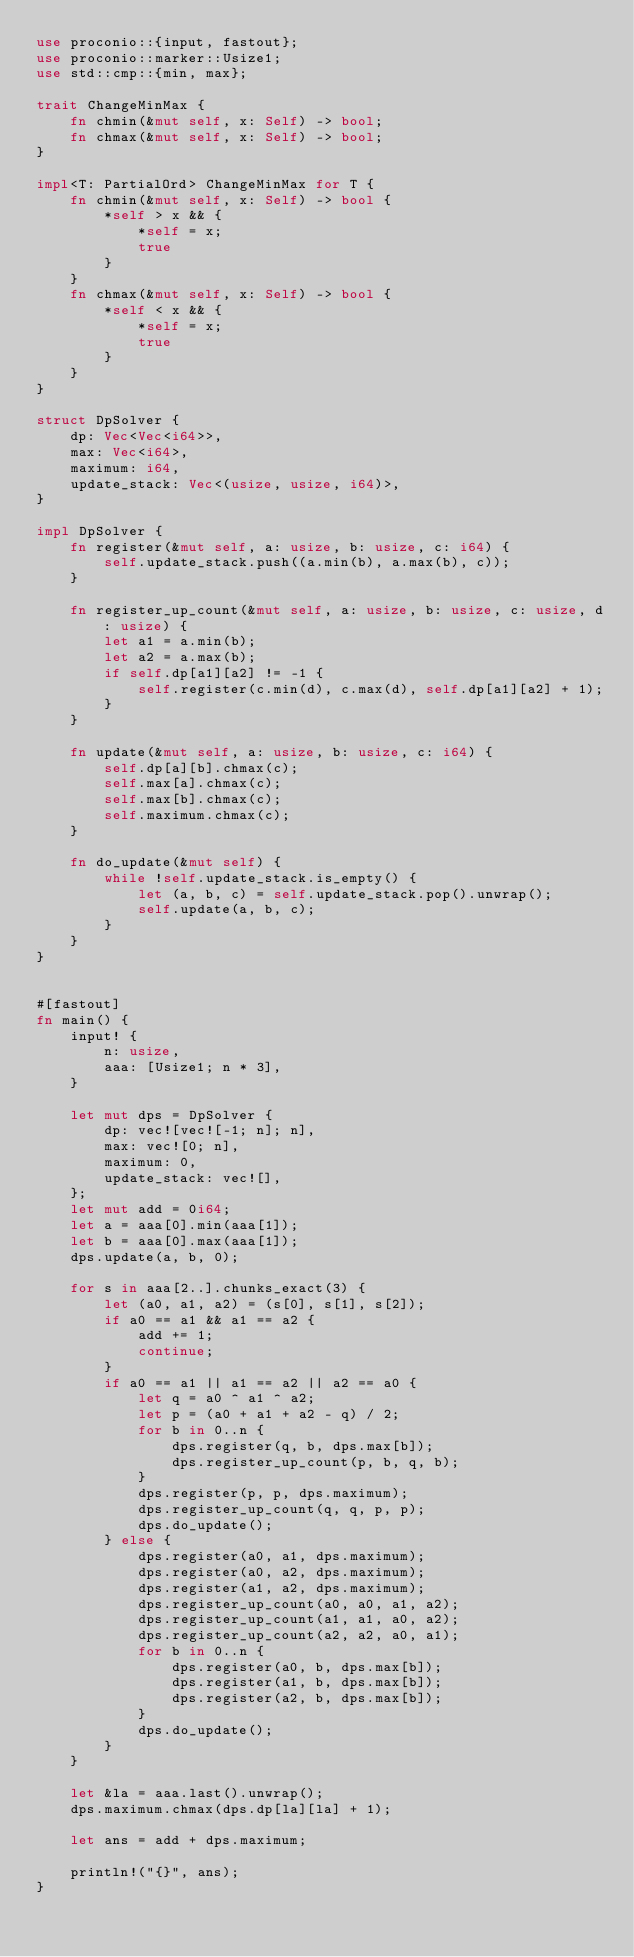Convert code to text. <code><loc_0><loc_0><loc_500><loc_500><_Rust_>use proconio::{input, fastout};
use proconio::marker::Usize1;
use std::cmp::{min, max};

trait ChangeMinMax {
    fn chmin(&mut self, x: Self) -> bool;
    fn chmax(&mut self, x: Self) -> bool;
}

impl<T: PartialOrd> ChangeMinMax for T {
    fn chmin(&mut self, x: Self) -> bool {
        *self > x && {
            *self = x;
            true
        }
    }
    fn chmax(&mut self, x: Self) -> bool {
        *self < x && {
            *self = x;
            true
        }
    }
}

struct DpSolver {
    dp: Vec<Vec<i64>>,
    max: Vec<i64>,
    maximum: i64,
    update_stack: Vec<(usize, usize, i64)>,
}

impl DpSolver {
    fn register(&mut self, a: usize, b: usize, c: i64) {
        self.update_stack.push((a.min(b), a.max(b), c));
    }

    fn register_up_count(&mut self, a: usize, b: usize, c: usize, d: usize) {
        let a1 = a.min(b);
        let a2 = a.max(b);
        if self.dp[a1][a2] != -1 {
            self.register(c.min(d), c.max(d), self.dp[a1][a2] + 1);
        }
    }

    fn update(&mut self, a: usize, b: usize, c: i64) {
        self.dp[a][b].chmax(c);
        self.max[a].chmax(c);
        self.max[b].chmax(c);
        self.maximum.chmax(c);
    }

    fn do_update(&mut self) {
        while !self.update_stack.is_empty() {
            let (a, b, c) = self.update_stack.pop().unwrap();
            self.update(a, b, c);
        }
    }
}


#[fastout]
fn main() {
    input! {
        n: usize,
        aaa: [Usize1; n * 3],
    }

    let mut dps = DpSolver {
        dp: vec![vec![-1; n]; n],
        max: vec![0; n],
        maximum: 0,
        update_stack: vec![],
    };
    let mut add = 0i64;
    let a = aaa[0].min(aaa[1]);
    let b = aaa[0].max(aaa[1]);
    dps.update(a, b, 0);

    for s in aaa[2..].chunks_exact(3) {
        let (a0, a1, a2) = (s[0], s[1], s[2]);
        if a0 == a1 && a1 == a2 {
            add += 1;
            continue;
        }
        if a0 == a1 || a1 == a2 || a2 == a0 {
            let q = a0 ^ a1 ^ a2;
            let p = (a0 + a1 + a2 - q) / 2;
            for b in 0..n {
                dps.register(q, b, dps.max[b]);
                dps.register_up_count(p, b, q, b);
            }
            dps.register(p, p, dps.maximum);
            dps.register_up_count(q, q, p, p);
            dps.do_update();
        } else {
            dps.register(a0, a1, dps.maximum);
            dps.register(a0, a2, dps.maximum);
            dps.register(a1, a2, dps.maximum);
            dps.register_up_count(a0, a0, a1, a2);
            dps.register_up_count(a1, a1, a0, a2);
            dps.register_up_count(a2, a2, a0, a1);
            for b in 0..n {
                dps.register(a0, b, dps.max[b]);
                dps.register(a1, b, dps.max[b]);
                dps.register(a2, b, dps.max[b]);
            }
            dps.do_update();
        }
    }

    let &la = aaa.last().unwrap();
    dps.maximum.chmax(dps.dp[la][la] + 1);

    let ans = add + dps.maximum;

    println!("{}", ans);
}
</code> 